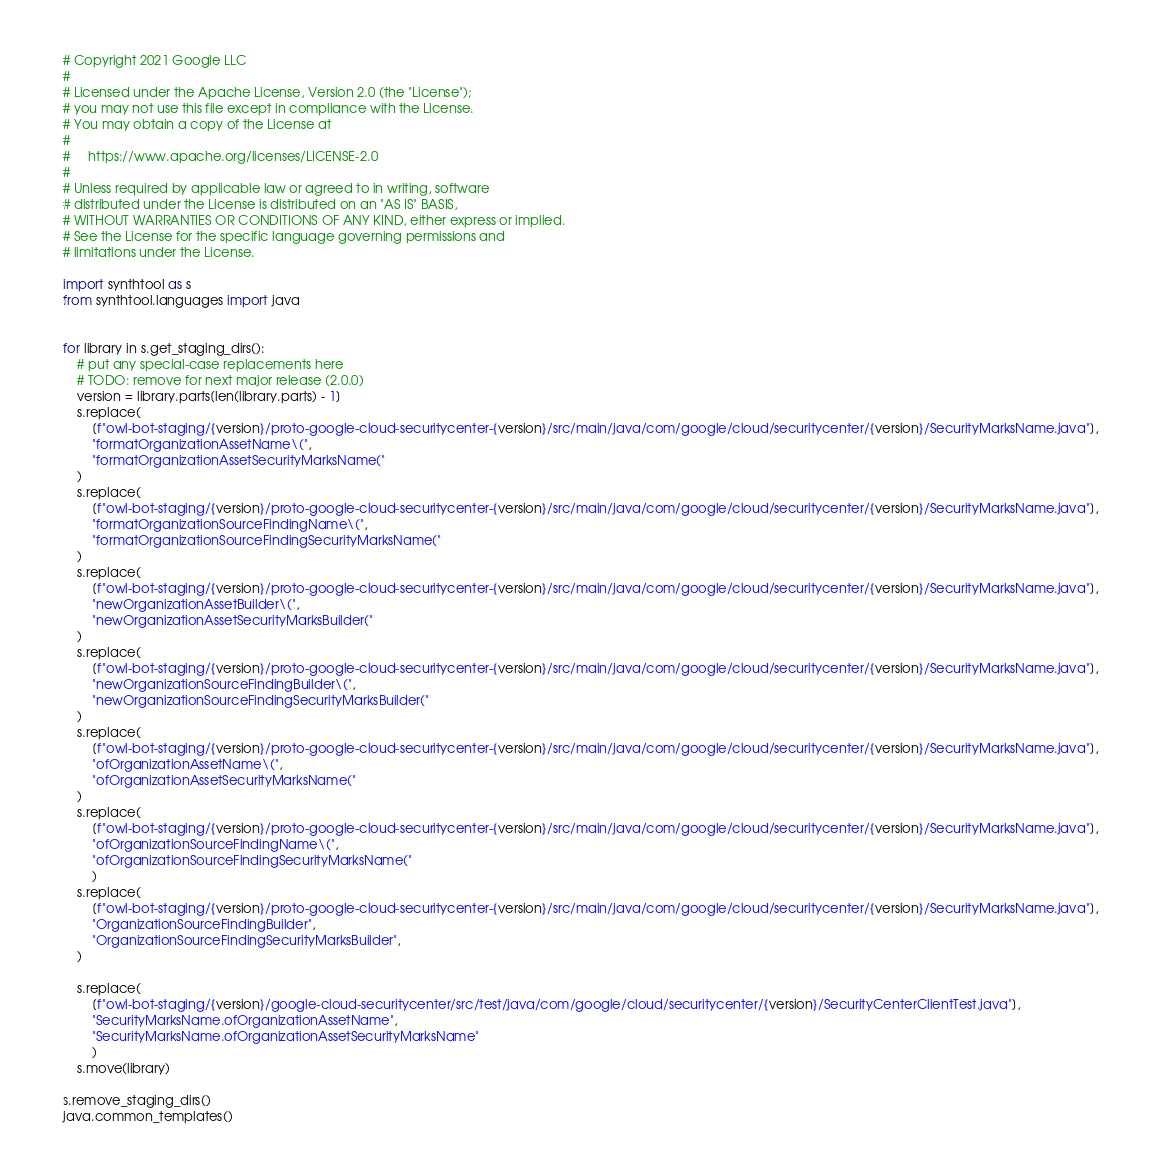<code> <loc_0><loc_0><loc_500><loc_500><_Python_># Copyright 2021 Google LLC
#
# Licensed under the Apache License, Version 2.0 (the "License");
# you may not use this file except in compliance with the License.
# You may obtain a copy of the License at
#
#     https://www.apache.org/licenses/LICENSE-2.0
#
# Unless required by applicable law or agreed to in writing, software
# distributed under the License is distributed on an "AS IS" BASIS,
# WITHOUT WARRANTIES OR CONDITIONS OF ANY KIND, either express or implied.
# See the License for the specific language governing permissions and
# limitations under the License.

import synthtool as s
from synthtool.languages import java


for library in s.get_staging_dirs():
    # put any special-case replacements here
    # TODO: remove for next major release (2.0.0)
    version = library.parts[len(library.parts) - 1]
    s.replace(
        [f"owl-bot-staging/{version}/proto-google-cloud-securitycenter-{version}/src/main/java/com/google/cloud/securitycenter/{version}/SecurityMarksName.java"],
        "formatOrganizationAssetName\(",
        "formatOrganizationAssetSecurityMarksName("
    )
    s.replace(
        [f"owl-bot-staging/{version}/proto-google-cloud-securitycenter-{version}/src/main/java/com/google/cloud/securitycenter/{version}/SecurityMarksName.java"],
        "formatOrganizationSourceFindingName\(",
        "formatOrganizationSourceFindingSecurityMarksName("
    )
    s.replace(
        [f"owl-bot-staging/{version}/proto-google-cloud-securitycenter-{version}/src/main/java/com/google/cloud/securitycenter/{version}/SecurityMarksName.java"],
        "newOrganizationAssetBuilder\(",
        "newOrganizationAssetSecurityMarksBuilder("
    )
    s.replace(
        [f"owl-bot-staging/{version}/proto-google-cloud-securitycenter-{version}/src/main/java/com/google/cloud/securitycenter/{version}/SecurityMarksName.java"],
        "newOrganizationSourceFindingBuilder\(",
        "newOrganizationSourceFindingSecurityMarksBuilder("
    )
    s.replace(
        [f"owl-bot-staging/{version}/proto-google-cloud-securitycenter-{version}/src/main/java/com/google/cloud/securitycenter/{version}/SecurityMarksName.java"],
        "ofOrganizationAssetName\(",
        "ofOrganizationAssetSecurityMarksName("
    )
    s.replace(
        [f"owl-bot-staging/{version}/proto-google-cloud-securitycenter-{version}/src/main/java/com/google/cloud/securitycenter/{version}/SecurityMarksName.java"],
        "ofOrganizationSourceFindingName\(",
        "ofOrganizationSourceFindingSecurityMarksName("
        )
    s.replace(
        [f"owl-bot-staging/{version}/proto-google-cloud-securitycenter-{version}/src/main/java/com/google/cloud/securitycenter/{version}/SecurityMarksName.java"],
        "OrganizationSourceFindingBuilder",
        "OrganizationSourceFindingSecurityMarksBuilder",
    )
    
    s.replace(
        [f"owl-bot-staging/{version}/google-cloud-securitycenter/src/test/java/com/google/cloud/securitycenter/{version}/SecurityCenterClientTest.java"],
        "SecurityMarksName.ofOrganizationAssetName",
        "SecurityMarksName.ofOrganizationAssetSecurityMarksName"
        )
    s.move(library)

s.remove_staging_dirs()
java.common_templates()
</code> 